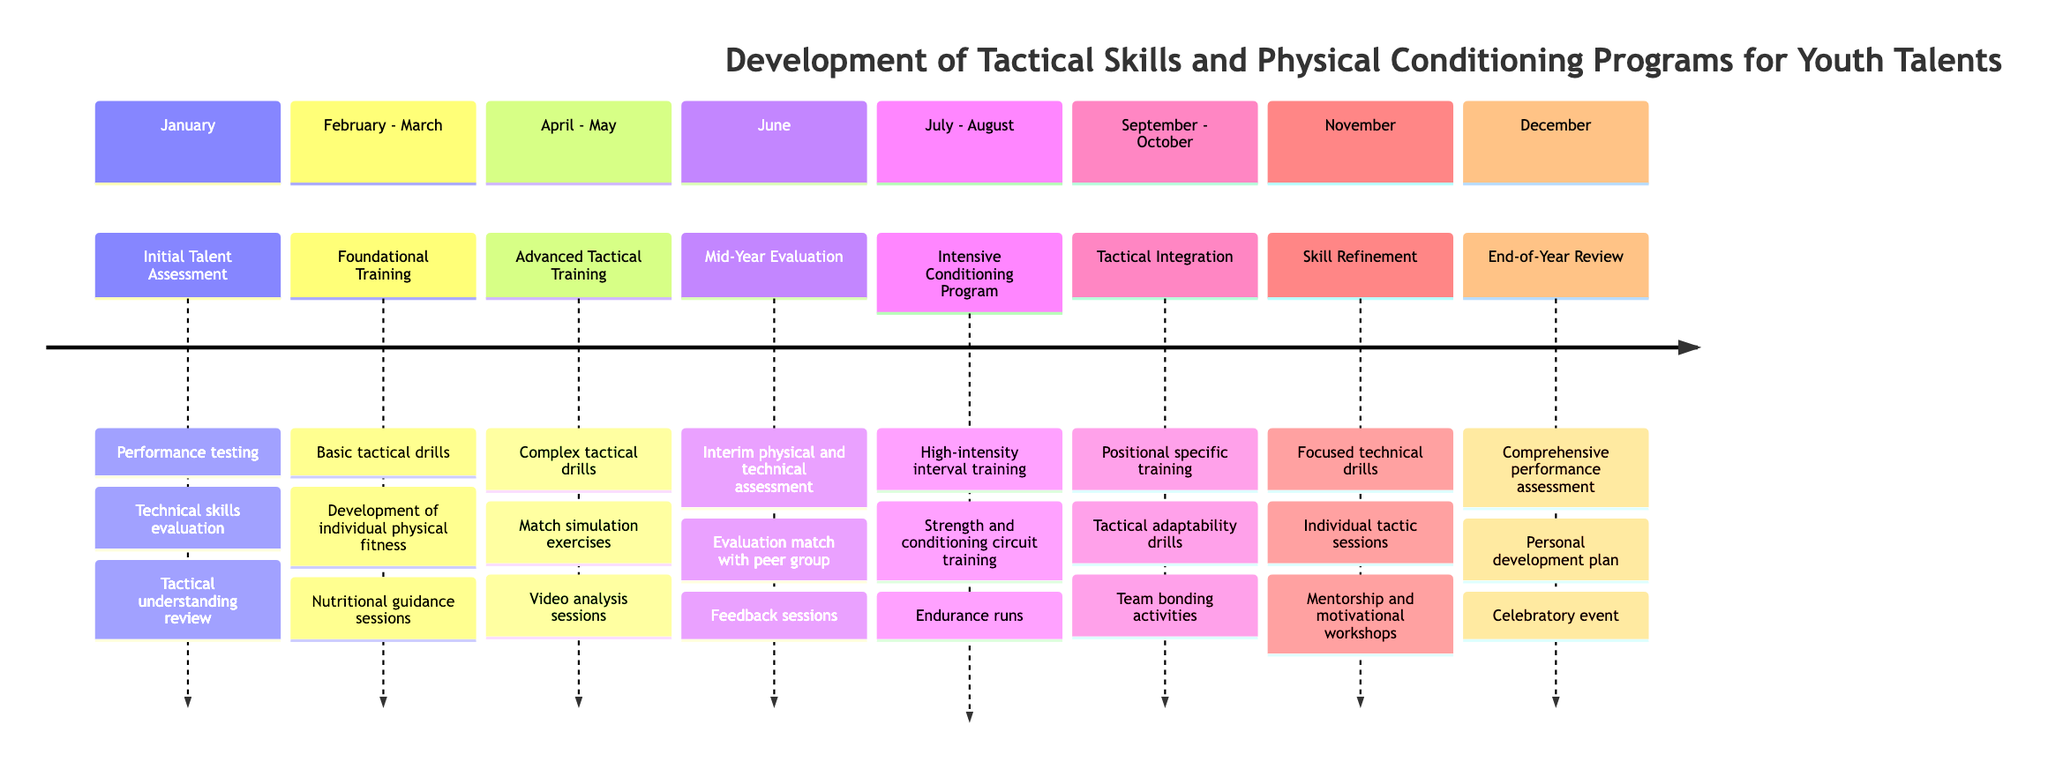what activities are included in the Initial Talent Assessment? The diagram shows that the Initial Talent Assessment includes performance testing, technical skills evaluation, and tactical understanding review. These activities help gauge the players' starting levels in various skills and fitness.
Answer: performance testing, technical skills evaluation, tactical understanding review which month marks the start of Advanced Tactical Training? The diagram indicates that Advanced Tactical Training begins in April and runs through May. This section shows a significant development phase for tactical skills.
Answer: April how many total activities are planned for the Mid-Year Evaluation? According to the diagram, the Mid-Year Evaluation consists of three activities: interim physical and technical assessment, evaluation match with peer group, and feedback sessions. Therefore, the total count of activities here is three.
Answer: 3 what kind of training occurs during the Intensive Conditioning Program? The diagram outlines three specific types of training in the Intensive Conditioning Program: high-intensity interval training, strength and conditioning circuit training, and endurance runs. This presents a rigorous approach to physical conditioning.
Answer: high-intensity interval training, strength and conditioning circuit training, endurance runs what is the focus of activities in November? The activities listed for the month of November are centered around skill refinement, which includes focused technical drills, individual tactic sessions, and mentorship and motivational workshops. This suggests a concentrated effort on improving individual skills.
Answer: skill refinement which elements are included in the Tactical Integration phase? The diagram specifies that the Tactical Integration phase includes positional specific training, tactical adaptability drills, and team bonding activities. This integration phase aims at solidifying team tactics and relationships among players.
Answer: positional specific training, tactical adaptability drills, team bonding activities what is the last month for conducting activities in this timeline? By analyzing the timeline, December is indicated as the last month for conducting activities. This month features the End-of-Year Review, summarizing the overall progress made throughout the year.
Answer: December how long is the duration of the Foundational Training? The diagram shows that the Foundational Training spans from February through March, indicating a two-month duration. This training is crucial for establishing basic skills in young talents.
Answer: 2 months which activity involves using video analysis? The diagram indicates that video analysis sessions are part of the Advanced Tactical Training. This activity points to utilizing technology to enhance tactical understanding among young players.
Answer: video analysis sessions 